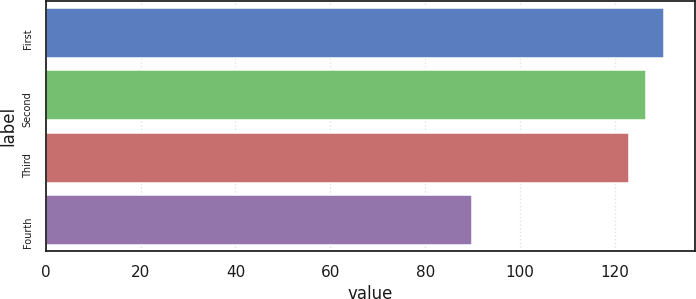Convert chart. <chart><loc_0><loc_0><loc_500><loc_500><bar_chart><fcel>First<fcel>Second<fcel>Third<fcel>Fourth<nl><fcel>130.42<fcel>126.65<fcel>122.88<fcel>89.76<nl></chart> 